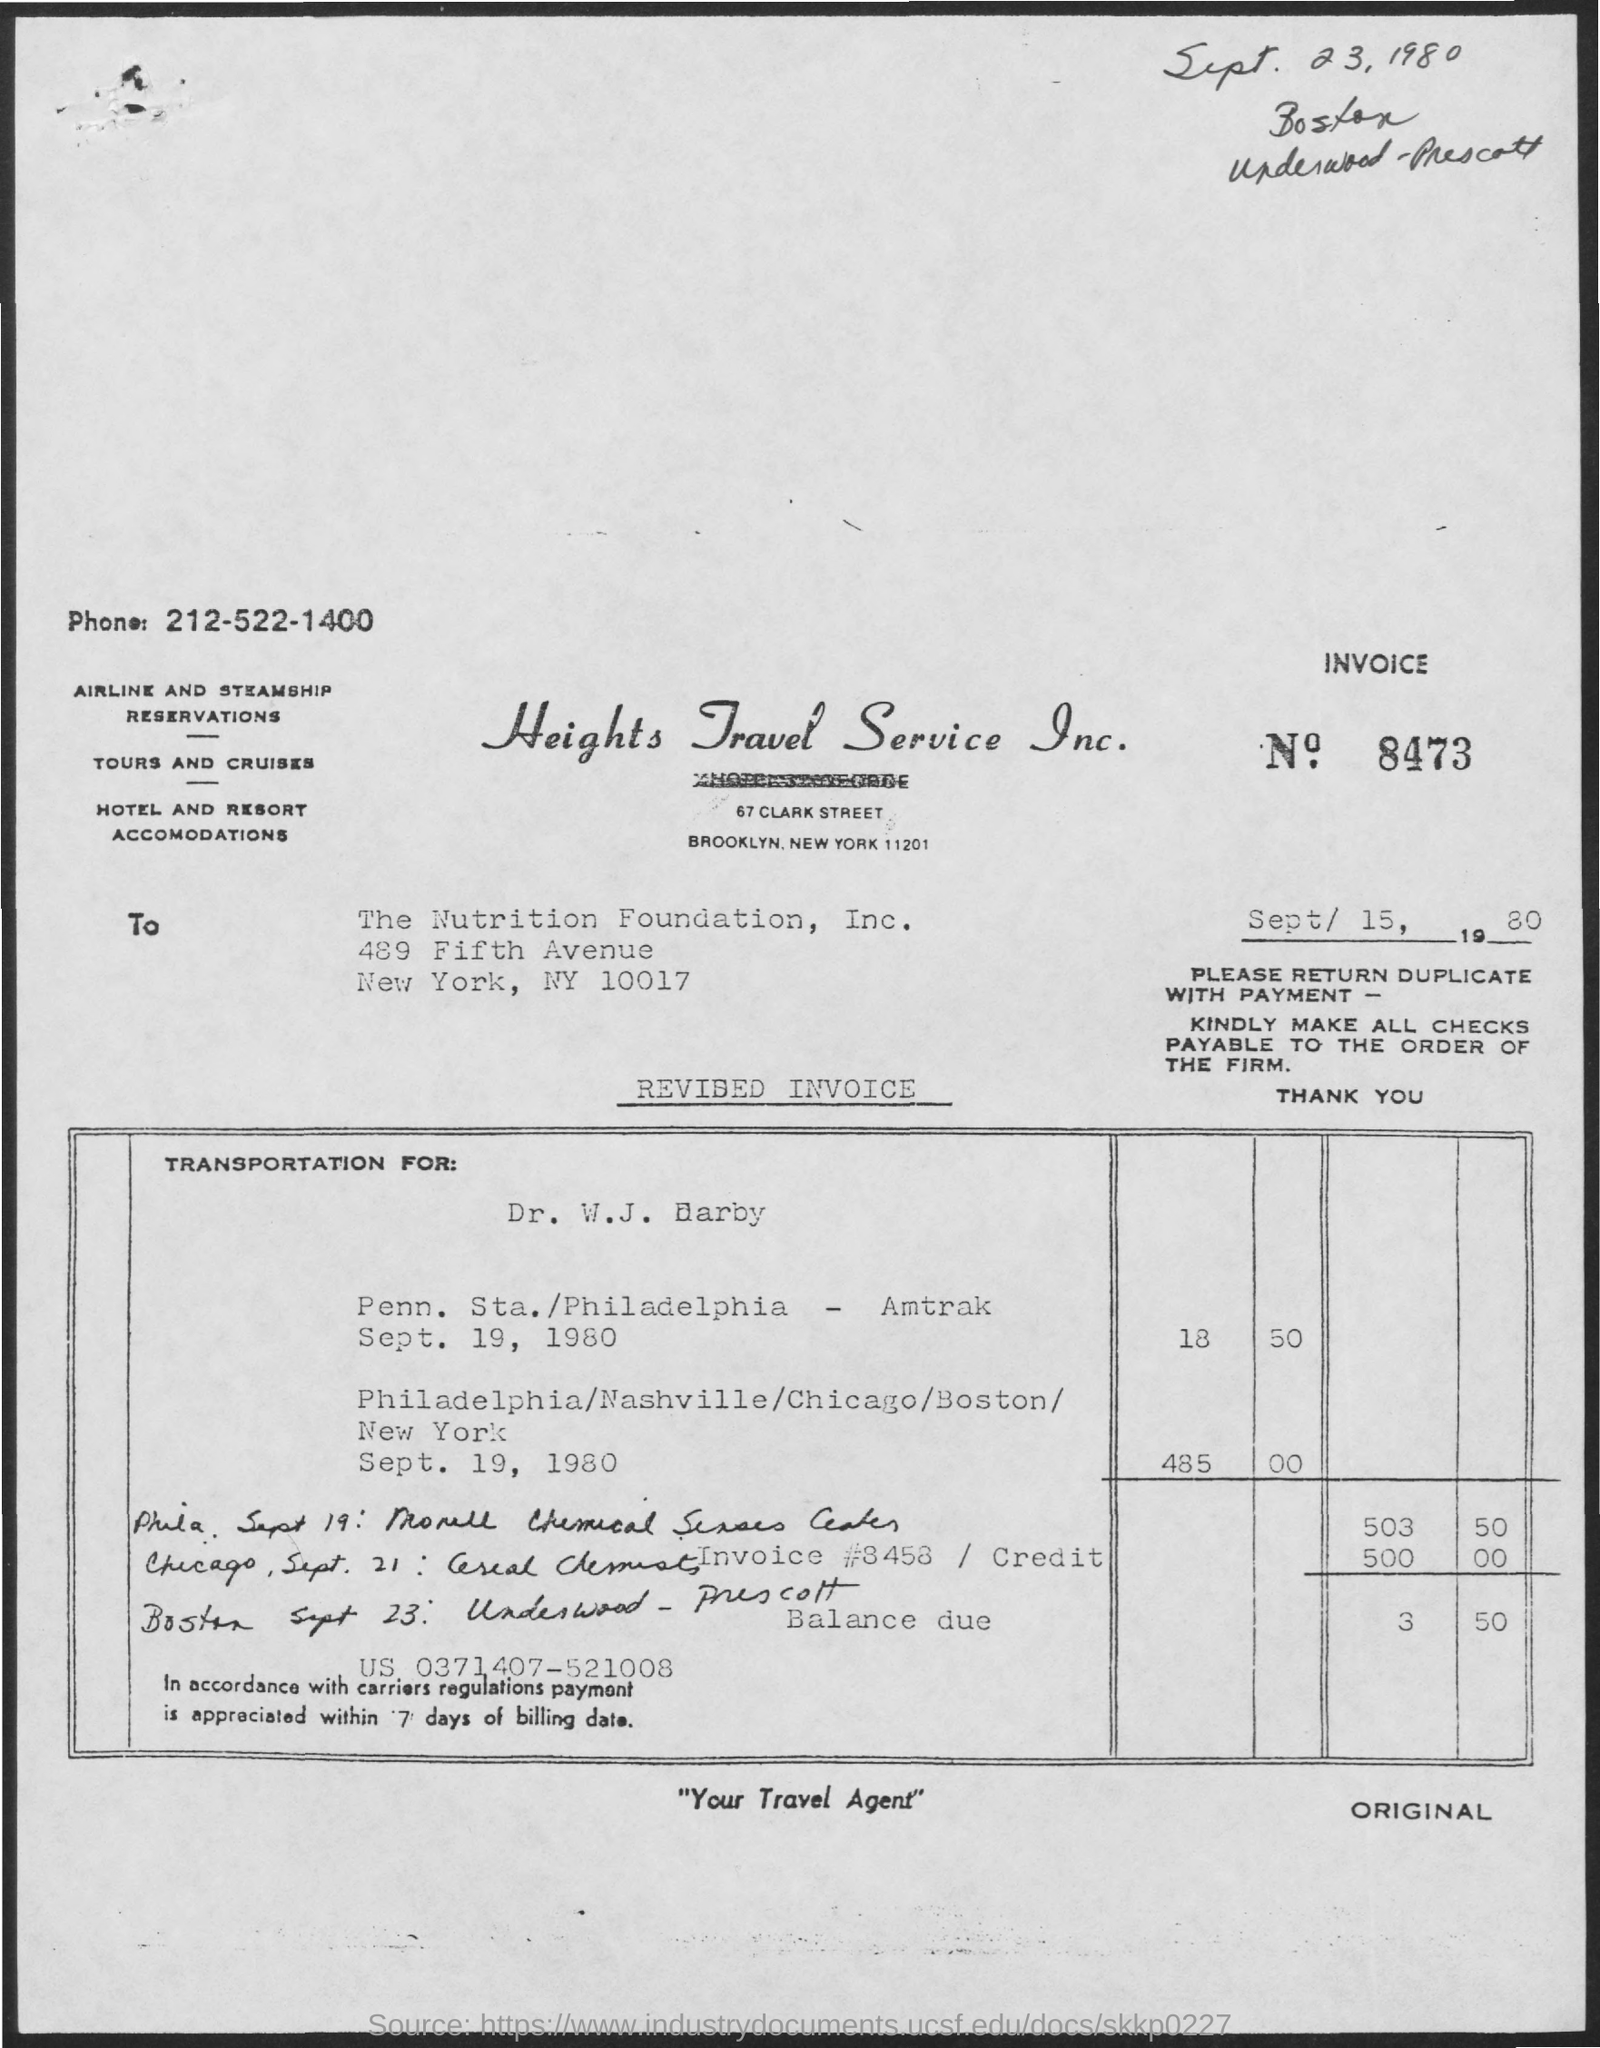Mention a couple of crucial points in this snapshot. The invoice number is 8473. Heights Travel Service Inc. can be reached by dialing the phone number 212-522-1400. Heights Travel Service Inc. declares itself to be a reliable and efficient travel agent, providing personalized service and expert advice to its clients. 